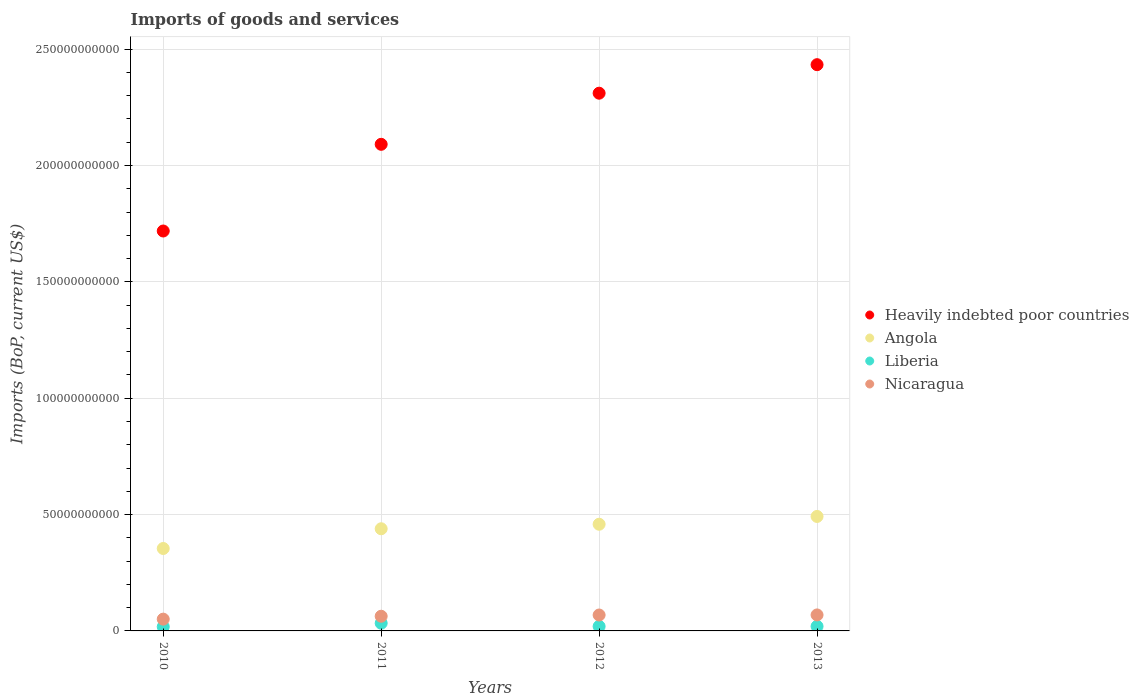How many different coloured dotlines are there?
Your answer should be very brief. 4. Is the number of dotlines equal to the number of legend labels?
Your answer should be compact. Yes. What is the amount spent on imports in Heavily indebted poor countries in 2011?
Your answer should be compact. 2.09e+11. Across all years, what is the maximum amount spent on imports in Heavily indebted poor countries?
Ensure brevity in your answer.  2.43e+11. Across all years, what is the minimum amount spent on imports in Nicaragua?
Your response must be concise. 5.06e+09. What is the total amount spent on imports in Heavily indebted poor countries in the graph?
Your answer should be very brief. 8.55e+11. What is the difference between the amount spent on imports in Liberia in 2010 and that in 2013?
Your answer should be compact. -1.64e+08. What is the difference between the amount spent on imports in Angola in 2013 and the amount spent on imports in Nicaragua in 2010?
Keep it short and to the point. 4.41e+1. What is the average amount spent on imports in Heavily indebted poor countries per year?
Your response must be concise. 2.14e+11. In the year 2012, what is the difference between the amount spent on imports in Nicaragua and amount spent on imports in Heavily indebted poor countries?
Provide a short and direct response. -2.24e+11. What is the ratio of the amount spent on imports in Nicaragua in 2011 to that in 2012?
Offer a very short reply. 0.92. What is the difference between the highest and the second highest amount spent on imports in Nicaragua?
Offer a very short reply. 3.58e+07. What is the difference between the highest and the lowest amount spent on imports in Heavily indebted poor countries?
Your answer should be very brief. 7.15e+1. In how many years, is the amount spent on imports in Heavily indebted poor countries greater than the average amount spent on imports in Heavily indebted poor countries taken over all years?
Your answer should be very brief. 2. What is the difference between two consecutive major ticks on the Y-axis?
Offer a terse response. 5.00e+1. Are the values on the major ticks of Y-axis written in scientific E-notation?
Offer a very short reply. No. Does the graph contain any zero values?
Your response must be concise. No. Where does the legend appear in the graph?
Your answer should be very brief. Center right. How many legend labels are there?
Your answer should be compact. 4. How are the legend labels stacked?
Offer a very short reply. Vertical. What is the title of the graph?
Offer a very short reply. Imports of goods and services. Does "Czech Republic" appear as one of the legend labels in the graph?
Provide a succinct answer. No. What is the label or title of the Y-axis?
Your response must be concise. Imports (BoP, current US$). What is the Imports (BoP, current US$) of Heavily indebted poor countries in 2010?
Keep it short and to the point. 1.72e+11. What is the Imports (BoP, current US$) in Angola in 2010?
Your answer should be very brief. 3.54e+1. What is the Imports (BoP, current US$) of Liberia in 2010?
Give a very brief answer. 1.80e+09. What is the Imports (BoP, current US$) in Nicaragua in 2010?
Ensure brevity in your answer.  5.06e+09. What is the Imports (BoP, current US$) in Heavily indebted poor countries in 2011?
Your answer should be compact. 2.09e+11. What is the Imports (BoP, current US$) in Angola in 2011?
Your answer should be compact. 4.39e+1. What is the Imports (BoP, current US$) in Liberia in 2011?
Your answer should be compact. 3.31e+09. What is the Imports (BoP, current US$) of Nicaragua in 2011?
Your response must be concise. 6.30e+09. What is the Imports (BoP, current US$) in Heavily indebted poor countries in 2012?
Provide a succinct answer. 2.31e+11. What is the Imports (BoP, current US$) of Angola in 2012?
Provide a short and direct response. 4.58e+1. What is the Imports (BoP, current US$) in Liberia in 2012?
Provide a short and direct response. 1.95e+09. What is the Imports (BoP, current US$) in Nicaragua in 2012?
Your answer should be compact. 6.84e+09. What is the Imports (BoP, current US$) in Heavily indebted poor countries in 2013?
Keep it short and to the point. 2.43e+11. What is the Imports (BoP, current US$) in Angola in 2013?
Make the answer very short. 4.92e+1. What is the Imports (BoP, current US$) in Liberia in 2013?
Ensure brevity in your answer.  1.96e+09. What is the Imports (BoP, current US$) in Nicaragua in 2013?
Make the answer very short. 6.87e+09. Across all years, what is the maximum Imports (BoP, current US$) of Heavily indebted poor countries?
Provide a succinct answer. 2.43e+11. Across all years, what is the maximum Imports (BoP, current US$) of Angola?
Your answer should be compact. 4.92e+1. Across all years, what is the maximum Imports (BoP, current US$) in Liberia?
Your answer should be very brief. 3.31e+09. Across all years, what is the maximum Imports (BoP, current US$) of Nicaragua?
Ensure brevity in your answer.  6.87e+09. Across all years, what is the minimum Imports (BoP, current US$) in Heavily indebted poor countries?
Offer a very short reply. 1.72e+11. Across all years, what is the minimum Imports (BoP, current US$) in Angola?
Give a very brief answer. 3.54e+1. Across all years, what is the minimum Imports (BoP, current US$) of Liberia?
Provide a short and direct response. 1.80e+09. Across all years, what is the minimum Imports (BoP, current US$) in Nicaragua?
Keep it short and to the point. 5.06e+09. What is the total Imports (BoP, current US$) of Heavily indebted poor countries in the graph?
Make the answer very short. 8.55e+11. What is the total Imports (BoP, current US$) of Angola in the graph?
Ensure brevity in your answer.  1.74e+11. What is the total Imports (BoP, current US$) in Liberia in the graph?
Offer a very short reply. 9.02e+09. What is the total Imports (BoP, current US$) of Nicaragua in the graph?
Provide a short and direct response. 2.51e+1. What is the difference between the Imports (BoP, current US$) of Heavily indebted poor countries in 2010 and that in 2011?
Ensure brevity in your answer.  -3.72e+1. What is the difference between the Imports (BoP, current US$) in Angola in 2010 and that in 2011?
Offer a very short reply. -8.48e+09. What is the difference between the Imports (BoP, current US$) in Liberia in 2010 and that in 2011?
Offer a very short reply. -1.51e+09. What is the difference between the Imports (BoP, current US$) in Nicaragua in 2010 and that in 2011?
Your answer should be very brief. -1.24e+09. What is the difference between the Imports (BoP, current US$) in Heavily indebted poor countries in 2010 and that in 2012?
Provide a succinct answer. -5.92e+1. What is the difference between the Imports (BoP, current US$) of Angola in 2010 and that in 2012?
Give a very brief answer. -1.04e+1. What is the difference between the Imports (BoP, current US$) in Liberia in 2010 and that in 2012?
Offer a very short reply. -1.54e+08. What is the difference between the Imports (BoP, current US$) in Nicaragua in 2010 and that in 2012?
Offer a very short reply. -1.77e+09. What is the difference between the Imports (BoP, current US$) of Heavily indebted poor countries in 2010 and that in 2013?
Offer a very short reply. -7.15e+1. What is the difference between the Imports (BoP, current US$) in Angola in 2010 and that in 2013?
Give a very brief answer. -1.38e+1. What is the difference between the Imports (BoP, current US$) in Liberia in 2010 and that in 2013?
Ensure brevity in your answer.  -1.64e+08. What is the difference between the Imports (BoP, current US$) of Nicaragua in 2010 and that in 2013?
Provide a succinct answer. -1.81e+09. What is the difference between the Imports (BoP, current US$) in Heavily indebted poor countries in 2011 and that in 2012?
Your answer should be very brief. -2.20e+1. What is the difference between the Imports (BoP, current US$) in Angola in 2011 and that in 2012?
Your answer should be compact. -1.94e+09. What is the difference between the Imports (BoP, current US$) of Liberia in 2011 and that in 2012?
Offer a very short reply. 1.36e+09. What is the difference between the Imports (BoP, current US$) of Nicaragua in 2011 and that in 2012?
Give a very brief answer. -5.32e+08. What is the difference between the Imports (BoP, current US$) in Heavily indebted poor countries in 2011 and that in 2013?
Your answer should be compact. -3.42e+1. What is the difference between the Imports (BoP, current US$) in Angola in 2011 and that in 2013?
Your response must be concise. -5.29e+09. What is the difference between the Imports (BoP, current US$) in Liberia in 2011 and that in 2013?
Ensure brevity in your answer.  1.35e+09. What is the difference between the Imports (BoP, current US$) in Nicaragua in 2011 and that in 2013?
Provide a succinct answer. -5.68e+08. What is the difference between the Imports (BoP, current US$) of Heavily indebted poor countries in 2012 and that in 2013?
Ensure brevity in your answer.  -1.23e+1. What is the difference between the Imports (BoP, current US$) in Angola in 2012 and that in 2013?
Offer a very short reply. -3.35e+09. What is the difference between the Imports (BoP, current US$) in Liberia in 2012 and that in 2013?
Offer a very short reply. -9.95e+06. What is the difference between the Imports (BoP, current US$) in Nicaragua in 2012 and that in 2013?
Your answer should be compact. -3.58e+07. What is the difference between the Imports (BoP, current US$) in Heavily indebted poor countries in 2010 and the Imports (BoP, current US$) in Angola in 2011?
Your response must be concise. 1.28e+11. What is the difference between the Imports (BoP, current US$) of Heavily indebted poor countries in 2010 and the Imports (BoP, current US$) of Liberia in 2011?
Provide a short and direct response. 1.69e+11. What is the difference between the Imports (BoP, current US$) in Heavily indebted poor countries in 2010 and the Imports (BoP, current US$) in Nicaragua in 2011?
Provide a short and direct response. 1.66e+11. What is the difference between the Imports (BoP, current US$) in Angola in 2010 and the Imports (BoP, current US$) in Liberia in 2011?
Your answer should be compact. 3.21e+1. What is the difference between the Imports (BoP, current US$) in Angola in 2010 and the Imports (BoP, current US$) in Nicaragua in 2011?
Provide a succinct answer. 2.91e+1. What is the difference between the Imports (BoP, current US$) in Liberia in 2010 and the Imports (BoP, current US$) in Nicaragua in 2011?
Your answer should be compact. -4.51e+09. What is the difference between the Imports (BoP, current US$) in Heavily indebted poor countries in 2010 and the Imports (BoP, current US$) in Angola in 2012?
Make the answer very short. 1.26e+11. What is the difference between the Imports (BoP, current US$) in Heavily indebted poor countries in 2010 and the Imports (BoP, current US$) in Liberia in 2012?
Keep it short and to the point. 1.70e+11. What is the difference between the Imports (BoP, current US$) of Heavily indebted poor countries in 2010 and the Imports (BoP, current US$) of Nicaragua in 2012?
Make the answer very short. 1.65e+11. What is the difference between the Imports (BoP, current US$) of Angola in 2010 and the Imports (BoP, current US$) of Liberia in 2012?
Provide a short and direct response. 3.35e+1. What is the difference between the Imports (BoP, current US$) of Angola in 2010 and the Imports (BoP, current US$) of Nicaragua in 2012?
Offer a very short reply. 2.86e+1. What is the difference between the Imports (BoP, current US$) in Liberia in 2010 and the Imports (BoP, current US$) in Nicaragua in 2012?
Make the answer very short. -5.04e+09. What is the difference between the Imports (BoP, current US$) of Heavily indebted poor countries in 2010 and the Imports (BoP, current US$) of Angola in 2013?
Provide a short and direct response. 1.23e+11. What is the difference between the Imports (BoP, current US$) of Heavily indebted poor countries in 2010 and the Imports (BoP, current US$) of Liberia in 2013?
Provide a short and direct response. 1.70e+11. What is the difference between the Imports (BoP, current US$) in Heavily indebted poor countries in 2010 and the Imports (BoP, current US$) in Nicaragua in 2013?
Ensure brevity in your answer.  1.65e+11. What is the difference between the Imports (BoP, current US$) of Angola in 2010 and the Imports (BoP, current US$) of Liberia in 2013?
Ensure brevity in your answer.  3.35e+1. What is the difference between the Imports (BoP, current US$) in Angola in 2010 and the Imports (BoP, current US$) in Nicaragua in 2013?
Offer a terse response. 2.85e+1. What is the difference between the Imports (BoP, current US$) in Liberia in 2010 and the Imports (BoP, current US$) in Nicaragua in 2013?
Offer a very short reply. -5.07e+09. What is the difference between the Imports (BoP, current US$) in Heavily indebted poor countries in 2011 and the Imports (BoP, current US$) in Angola in 2012?
Keep it short and to the point. 1.63e+11. What is the difference between the Imports (BoP, current US$) of Heavily indebted poor countries in 2011 and the Imports (BoP, current US$) of Liberia in 2012?
Give a very brief answer. 2.07e+11. What is the difference between the Imports (BoP, current US$) of Heavily indebted poor countries in 2011 and the Imports (BoP, current US$) of Nicaragua in 2012?
Your response must be concise. 2.02e+11. What is the difference between the Imports (BoP, current US$) in Angola in 2011 and the Imports (BoP, current US$) in Liberia in 2012?
Your answer should be very brief. 4.19e+1. What is the difference between the Imports (BoP, current US$) in Angola in 2011 and the Imports (BoP, current US$) in Nicaragua in 2012?
Your response must be concise. 3.71e+1. What is the difference between the Imports (BoP, current US$) in Liberia in 2011 and the Imports (BoP, current US$) in Nicaragua in 2012?
Your answer should be very brief. -3.53e+09. What is the difference between the Imports (BoP, current US$) of Heavily indebted poor countries in 2011 and the Imports (BoP, current US$) of Angola in 2013?
Keep it short and to the point. 1.60e+11. What is the difference between the Imports (BoP, current US$) in Heavily indebted poor countries in 2011 and the Imports (BoP, current US$) in Liberia in 2013?
Your answer should be compact. 2.07e+11. What is the difference between the Imports (BoP, current US$) in Heavily indebted poor countries in 2011 and the Imports (BoP, current US$) in Nicaragua in 2013?
Keep it short and to the point. 2.02e+11. What is the difference between the Imports (BoP, current US$) of Angola in 2011 and the Imports (BoP, current US$) of Liberia in 2013?
Your answer should be very brief. 4.19e+1. What is the difference between the Imports (BoP, current US$) in Angola in 2011 and the Imports (BoP, current US$) in Nicaragua in 2013?
Your answer should be compact. 3.70e+1. What is the difference between the Imports (BoP, current US$) of Liberia in 2011 and the Imports (BoP, current US$) of Nicaragua in 2013?
Ensure brevity in your answer.  -3.56e+09. What is the difference between the Imports (BoP, current US$) of Heavily indebted poor countries in 2012 and the Imports (BoP, current US$) of Angola in 2013?
Keep it short and to the point. 1.82e+11. What is the difference between the Imports (BoP, current US$) in Heavily indebted poor countries in 2012 and the Imports (BoP, current US$) in Liberia in 2013?
Ensure brevity in your answer.  2.29e+11. What is the difference between the Imports (BoP, current US$) of Heavily indebted poor countries in 2012 and the Imports (BoP, current US$) of Nicaragua in 2013?
Ensure brevity in your answer.  2.24e+11. What is the difference between the Imports (BoP, current US$) of Angola in 2012 and the Imports (BoP, current US$) of Liberia in 2013?
Provide a short and direct response. 4.39e+1. What is the difference between the Imports (BoP, current US$) of Angola in 2012 and the Imports (BoP, current US$) of Nicaragua in 2013?
Make the answer very short. 3.90e+1. What is the difference between the Imports (BoP, current US$) in Liberia in 2012 and the Imports (BoP, current US$) in Nicaragua in 2013?
Give a very brief answer. -4.92e+09. What is the average Imports (BoP, current US$) in Heavily indebted poor countries per year?
Give a very brief answer. 2.14e+11. What is the average Imports (BoP, current US$) in Angola per year?
Offer a very short reply. 4.36e+1. What is the average Imports (BoP, current US$) of Liberia per year?
Provide a short and direct response. 2.26e+09. What is the average Imports (BoP, current US$) in Nicaragua per year?
Keep it short and to the point. 6.27e+09. In the year 2010, what is the difference between the Imports (BoP, current US$) in Heavily indebted poor countries and Imports (BoP, current US$) in Angola?
Provide a short and direct response. 1.36e+11. In the year 2010, what is the difference between the Imports (BoP, current US$) of Heavily indebted poor countries and Imports (BoP, current US$) of Liberia?
Keep it short and to the point. 1.70e+11. In the year 2010, what is the difference between the Imports (BoP, current US$) in Heavily indebted poor countries and Imports (BoP, current US$) in Nicaragua?
Your answer should be compact. 1.67e+11. In the year 2010, what is the difference between the Imports (BoP, current US$) in Angola and Imports (BoP, current US$) in Liberia?
Offer a terse response. 3.36e+1. In the year 2010, what is the difference between the Imports (BoP, current US$) in Angola and Imports (BoP, current US$) in Nicaragua?
Ensure brevity in your answer.  3.04e+1. In the year 2010, what is the difference between the Imports (BoP, current US$) of Liberia and Imports (BoP, current US$) of Nicaragua?
Provide a short and direct response. -3.27e+09. In the year 2011, what is the difference between the Imports (BoP, current US$) in Heavily indebted poor countries and Imports (BoP, current US$) in Angola?
Keep it short and to the point. 1.65e+11. In the year 2011, what is the difference between the Imports (BoP, current US$) of Heavily indebted poor countries and Imports (BoP, current US$) of Liberia?
Your response must be concise. 2.06e+11. In the year 2011, what is the difference between the Imports (BoP, current US$) in Heavily indebted poor countries and Imports (BoP, current US$) in Nicaragua?
Ensure brevity in your answer.  2.03e+11. In the year 2011, what is the difference between the Imports (BoP, current US$) of Angola and Imports (BoP, current US$) of Liberia?
Offer a very short reply. 4.06e+1. In the year 2011, what is the difference between the Imports (BoP, current US$) in Angola and Imports (BoP, current US$) in Nicaragua?
Your answer should be compact. 3.76e+1. In the year 2011, what is the difference between the Imports (BoP, current US$) in Liberia and Imports (BoP, current US$) in Nicaragua?
Provide a succinct answer. -2.99e+09. In the year 2012, what is the difference between the Imports (BoP, current US$) in Heavily indebted poor countries and Imports (BoP, current US$) in Angola?
Keep it short and to the point. 1.85e+11. In the year 2012, what is the difference between the Imports (BoP, current US$) of Heavily indebted poor countries and Imports (BoP, current US$) of Liberia?
Provide a succinct answer. 2.29e+11. In the year 2012, what is the difference between the Imports (BoP, current US$) of Heavily indebted poor countries and Imports (BoP, current US$) of Nicaragua?
Keep it short and to the point. 2.24e+11. In the year 2012, what is the difference between the Imports (BoP, current US$) in Angola and Imports (BoP, current US$) in Liberia?
Ensure brevity in your answer.  4.39e+1. In the year 2012, what is the difference between the Imports (BoP, current US$) in Angola and Imports (BoP, current US$) in Nicaragua?
Your response must be concise. 3.90e+1. In the year 2012, what is the difference between the Imports (BoP, current US$) in Liberia and Imports (BoP, current US$) in Nicaragua?
Provide a succinct answer. -4.88e+09. In the year 2013, what is the difference between the Imports (BoP, current US$) of Heavily indebted poor countries and Imports (BoP, current US$) of Angola?
Make the answer very short. 1.94e+11. In the year 2013, what is the difference between the Imports (BoP, current US$) of Heavily indebted poor countries and Imports (BoP, current US$) of Liberia?
Your response must be concise. 2.41e+11. In the year 2013, what is the difference between the Imports (BoP, current US$) of Heavily indebted poor countries and Imports (BoP, current US$) of Nicaragua?
Offer a very short reply. 2.36e+11. In the year 2013, what is the difference between the Imports (BoP, current US$) in Angola and Imports (BoP, current US$) in Liberia?
Keep it short and to the point. 4.72e+1. In the year 2013, what is the difference between the Imports (BoP, current US$) in Angola and Imports (BoP, current US$) in Nicaragua?
Give a very brief answer. 4.23e+1. In the year 2013, what is the difference between the Imports (BoP, current US$) of Liberia and Imports (BoP, current US$) of Nicaragua?
Offer a very short reply. -4.91e+09. What is the ratio of the Imports (BoP, current US$) in Heavily indebted poor countries in 2010 to that in 2011?
Provide a succinct answer. 0.82. What is the ratio of the Imports (BoP, current US$) in Angola in 2010 to that in 2011?
Your answer should be very brief. 0.81. What is the ratio of the Imports (BoP, current US$) in Liberia in 2010 to that in 2011?
Provide a short and direct response. 0.54. What is the ratio of the Imports (BoP, current US$) in Nicaragua in 2010 to that in 2011?
Offer a terse response. 0.8. What is the ratio of the Imports (BoP, current US$) in Heavily indebted poor countries in 2010 to that in 2012?
Provide a succinct answer. 0.74. What is the ratio of the Imports (BoP, current US$) of Angola in 2010 to that in 2012?
Make the answer very short. 0.77. What is the ratio of the Imports (BoP, current US$) in Liberia in 2010 to that in 2012?
Keep it short and to the point. 0.92. What is the ratio of the Imports (BoP, current US$) of Nicaragua in 2010 to that in 2012?
Your response must be concise. 0.74. What is the ratio of the Imports (BoP, current US$) of Heavily indebted poor countries in 2010 to that in 2013?
Provide a succinct answer. 0.71. What is the ratio of the Imports (BoP, current US$) in Angola in 2010 to that in 2013?
Provide a short and direct response. 0.72. What is the ratio of the Imports (BoP, current US$) in Liberia in 2010 to that in 2013?
Offer a terse response. 0.92. What is the ratio of the Imports (BoP, current US$) of Nicaragua in 2010 to that in 2013?
Offer a very short reply. 0.74. What is the ratio of the Imports (BoP, current US$) in Heavily indebted poor countries in 2011 to that in 2012?
Keep it short and to the point. 0.9. What is the ratio of the Imports (BoP, current US$) in Angola in 2011 to that in 2012?
Offer a terse response. 0.96. What is the ratio of the Imports (BoP, current US$) of Liberia in 2011 to that in 2012?
Provide a succinct answer. 1.7. What is the ratio of the Imports (BoP, current US$) in Nicaragua in 2011 to that in 2012?
Offer a terse response. 0.92. What is the ratio of the Imports (BoP, current US$) in Heavily indebted poor countries in 2011 to that in 2013?
Offer a very short reply. 0.86. What is the ratio of the Imports (BoP, current US$) in Angola in 2011 to that in 2013?
Provide a succinct answer. 0.89. What is the ratio of the Imports (BoP, current US$) of Liberia in 2011 to that in 2013?
Keep it short and to the point. 1.69. What is the ratio of the Imports (BoP, current US$) of Nicaragua in 2011 to that in 2013?
Offer a terse response. 0.92. What is the ratio of the Imports (BoP, current US$) of Heavily indebted poor countries in 2012 to that in 2013?
Make the answer very short. 0.95. What is the ratio of the Imports (BoP, current US$) in Angola in 2012 to that in 2013?
Offer a terse response. 0.93. What is the difference between the highest and the second highest Imports (BoP, current US$) of Heavily indebted poor countries?
Offer a terse response. 1.23e+1. What is the difference between the highest and the second highest Imports (BoP, current US$) in Angola?
Your answer should be compact. 3.35e+09. What is the difference between the highest and the second highest Imports (BoP, current US$) of Liberia?
Give a very brief answer. 1.35e+09. What is the difference between the highest and the second highest Imports (BoP, current US$) of Nicaragua?
Your answer should be very brief. 3.58e+07. What is the difference between the highest and the lowest Imports (BoP, current US$) of Heavily indebted poor countries?
Your response must be concise. 7.15e+1. What is the difference between the highest and the lowest Imports (BoP, current US$) of Angola?
Provide a short and direct response. 1.38e+1. What is the difference between the highest and the lowest Imports (BoP, current US$) of Liberia?
Ensure brevity in your answer.  1.51e+09. What is the difference between the highest and the lowest Imports (BoP, current US$) in Nicaragua?
Your response must be concise. 1.81e+09. 